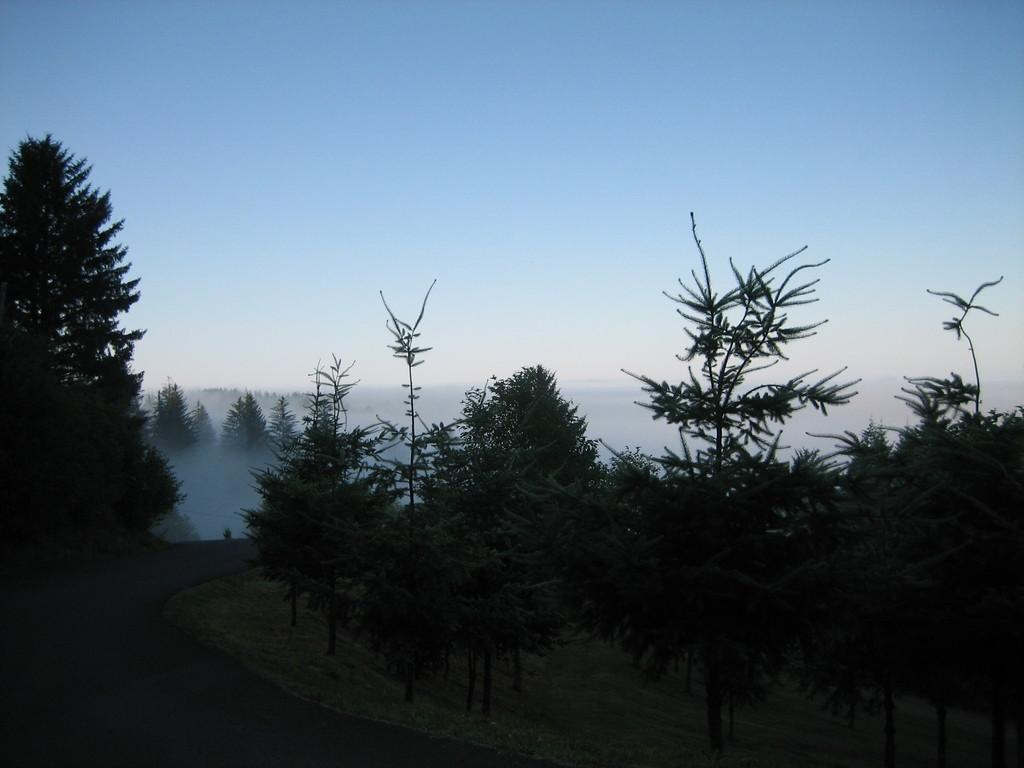What can be seen in the foreground of the picture? In the foreground of the picture, there are trees, grass, and a road. What is visible in the background of the picture? In the background of the picture, there is fog, trees, and the sky. What type of vegetation is present in the foreground and background of the picture? Trees are present in both the foreground and background of the picture. What is the weight of the ladybug on the road in the image? There is no ladybug present in the image, so it is not possible to determine its weight. How many sticks are visible in the image? There are no sticks visible in the image. 